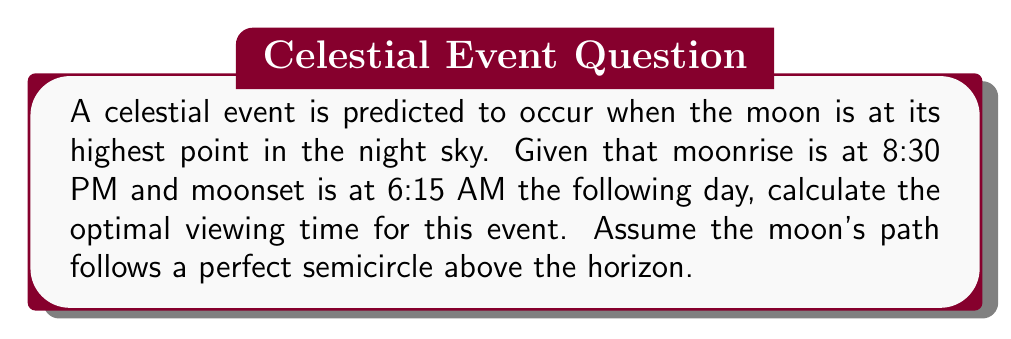Can you solve this math problem? To solve this problem, we need to follow these steps:

1. Calculate the total time the moon is visible:
   Moonset (6:15 AM) - Moonrise (8:30 PM) = 9 hours and 45 minutes = 9.75 hours

2. Since the moon's path is assumed to be a perfect semicircle, the highest point (optimal viewing time) will be exactly halfway between moonrise and moonset.

3. Calculate half of the total visible time:
   $\frac{9.75}{2} = 4.875$ hours

4. Add this time to the moonrise time:
   8:30 PM + 4.875 hours = 1:22:30 AM

5. Round to the nearest minute for practical purposes:
   1:23 AM

This calculation provides the optimal viewing time for the celestial event, which occurs when the moon is at its highest point in the sky. This information is crucial for town council members promoting dark sky tourism, as it allows for planning of guided viewing events and ensures visitors have the best possible experience observing celestial phenomena.
Answer: 1:23 AM 